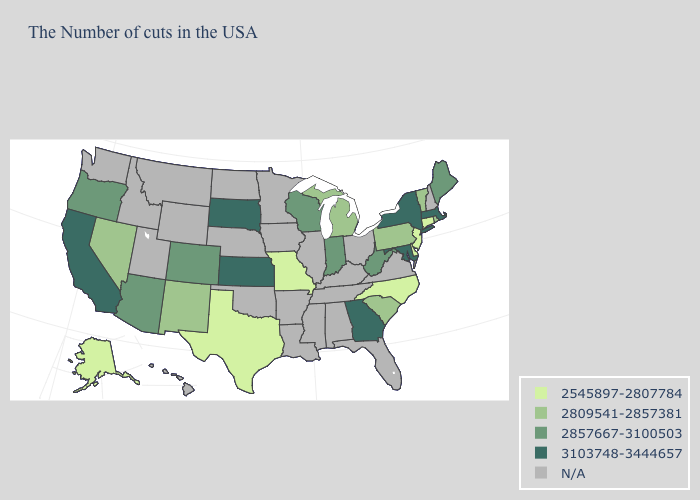Does South Dakota have the highest value in the MidWest?
Short answer required. Yes. What is the value of Vermont?
Keep it brief. 2809541-2857381. Does Georgia have the highest value in the South?
Keep it brief. Yes. What is the highest value in the Northeast ?
Keep it brief. 3103748-3444657. What is the lowest value in the USA?
Answer briefly. 2545897-2807784. What is the value of Wisconsin?
Concise answer only. 2857667-3100503. What is the value of Vermont?
Be succinct. 2809541-2857381. What is the value of South Carolina?
Write a very short answer. 2809541-2857381. Among the states that border Michigan , which have the highest value?
Write a very short answer. Indiana, Wisconsin. What is the lowest value in states that border Connecticut?
Give a very brief answer. 2809541-2857381. What is the highest value in the West ?
Give a very brief answer. 3103748-3444657. Name the states that have a value in the range 2857667-3100503?
Keep it brief. Maine, West Virginia, Indiana, Wisconsin, Colorado, Arizona, Oregon. What is the highest value in the West ?
Write a very short answer. 3103748-3444657. What is the value of Connecticut?
Give a very brief answer. 2545897-2807784. What is the value of Texas?
Quick response, please. 2545897-2807784. 